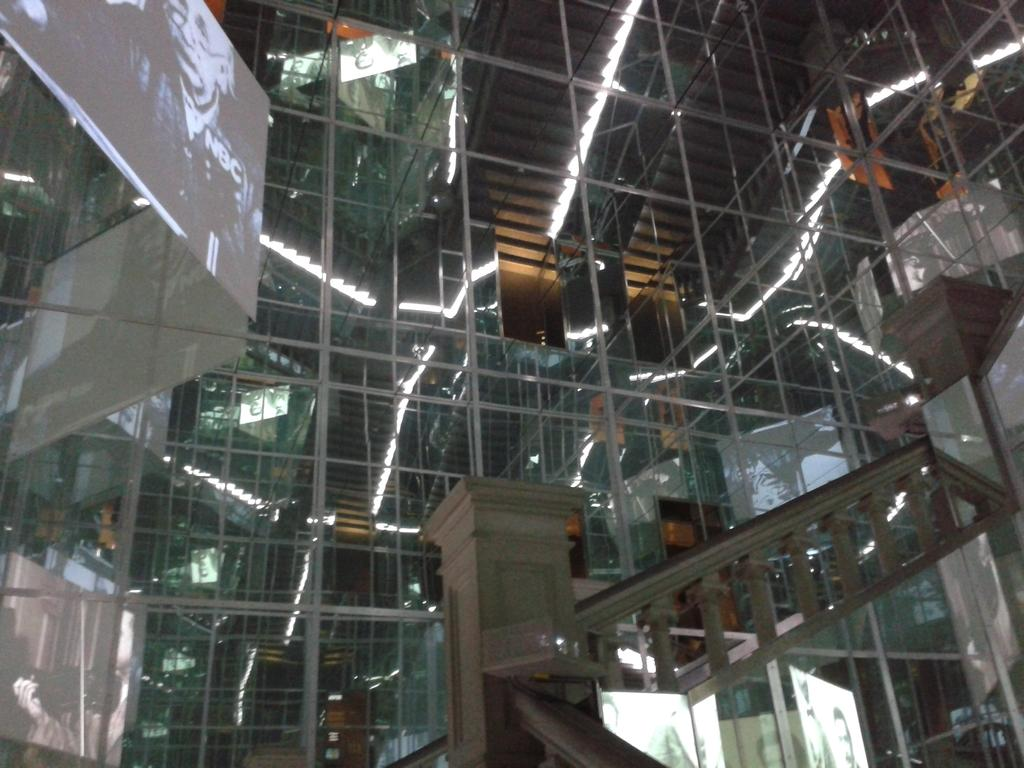What type of structure is visible in the image? There is a building in the image. What feature of the building is mentioned in the facts? The building has lights and a screen. Where is the staircase located in the image? The staircase is on the right side of the image. What type of mint is growing on the staircase in the image? There is no mint plant visible on the staircase in the image. What game is being played on the screen of the building? The facts provided do not mention any game being played on the screen of the building. 